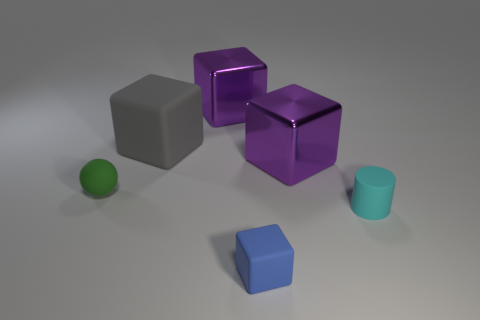Add 4 small rubber things. How many objects exist? 10 Subtract all cylinders. How many objects are left? 5 Add 6 cyan matte things. How many cyan matte things are left? 7 Add 5 yellow metallic cylinders. How many yellow metallic cylinders exist? 5 Subtract 0 brown cylinders. How many objects are left? 6 Subtract all large green metal cylinders. Subtract all gray rubber objects. How many objects are left? 5 